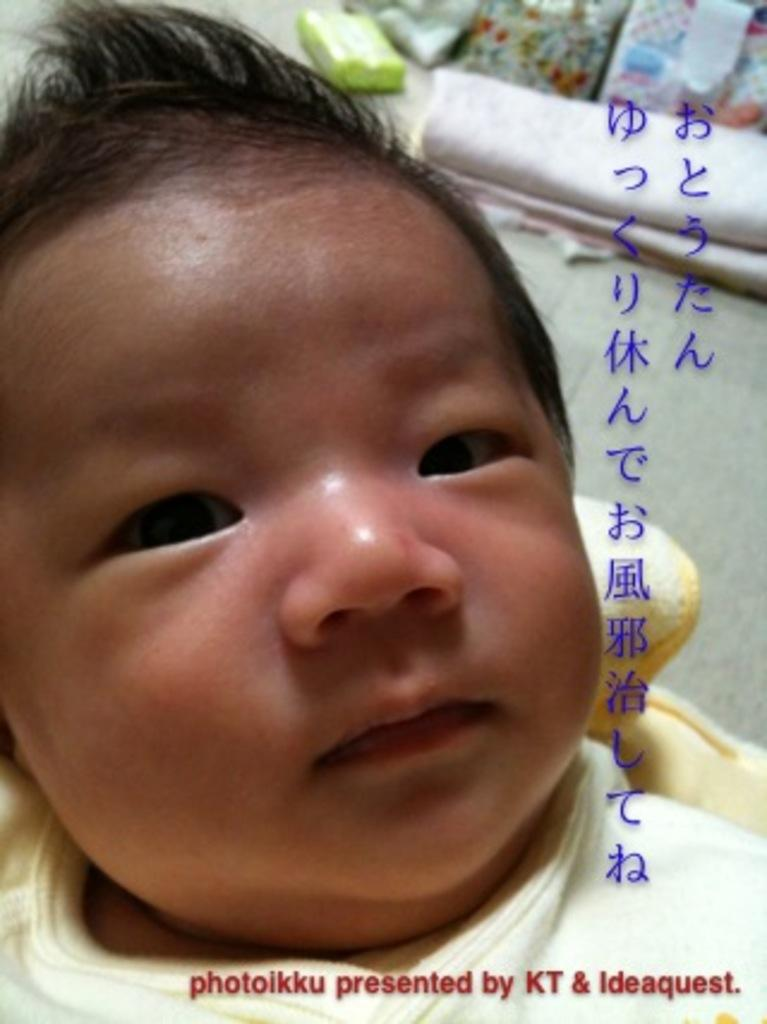What is the main subject of the image? There is a baby in the image. Is there any text present in the image? Yes, there is text in the image. What can be seen in the background of the image? There are objects in the background of the image. Can we determine the location of the image based on the provided facts? The image may have been taken in a room, but we cannot confirm this definitively. What type of waves can be seen crashing on the shore in the image? There are no waves or shore present in the image; it features a baby and text. Can you describe the field where the baby is playing in the image? There is no field present in the image; it may have been taken in a room. 